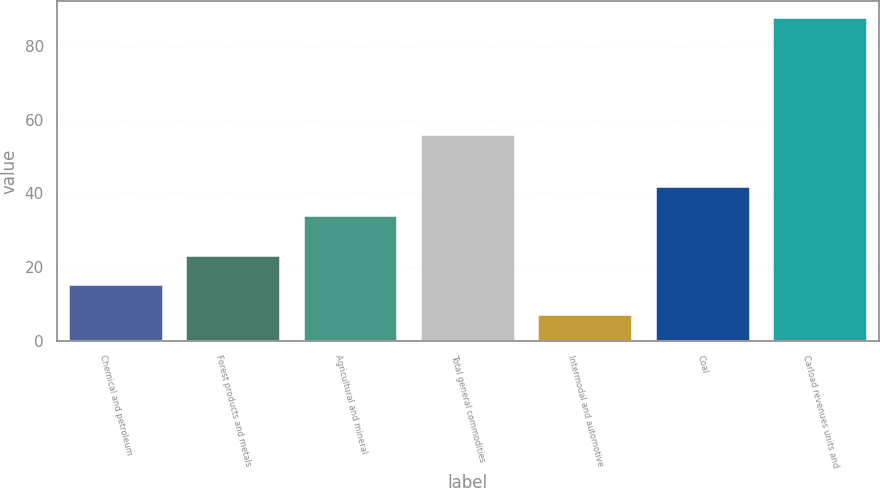Convert chart to OTSL. <chart><loc_0><loc_0><loc_500><loc_500><bar_chart><fcel>Chemical and petroleum<fcel>Forest products and metals<fcel>Agricultural and mineral<fcel>Total general commodities<fcel>Intermodal and automotive<fcel>Coal<fcel>Carload revenues units and<nl><fcel>14.98<fcel>23.06<fcel>33.7<fcel>55.9<fcel>6.9<fcel>41.78<fcel>87.7<nl></chart> 